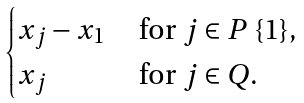Convert formula to latex. <formula><loc_0><loc_0><loc_500><loc_500>\begin{cases} x _ { j } - x _ { 1 } & \text { for } j \in P \ \{ 1 \} , \\ x _ { j } & \text { for } j \in Q . \end{cases}</formula> 